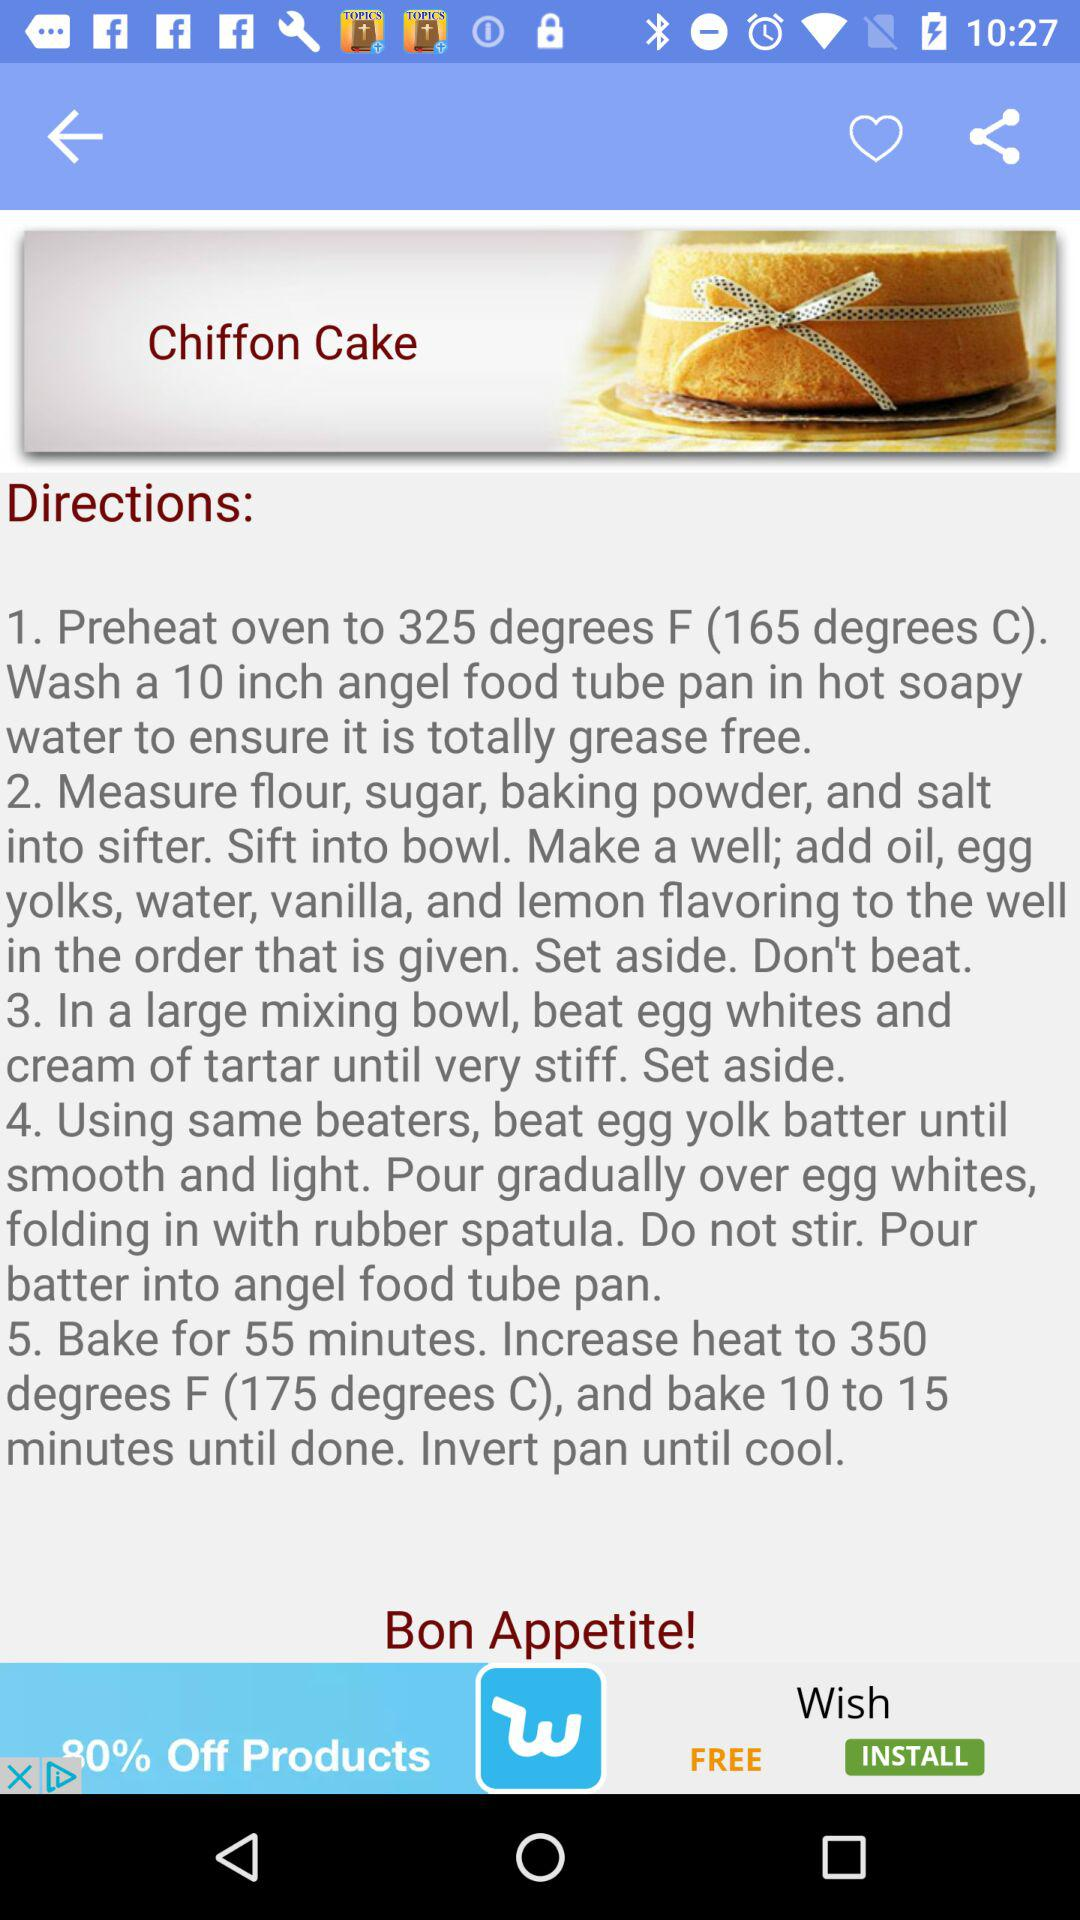What is the name of the recipe? The name of the recipe is "Chiffon Cake". 